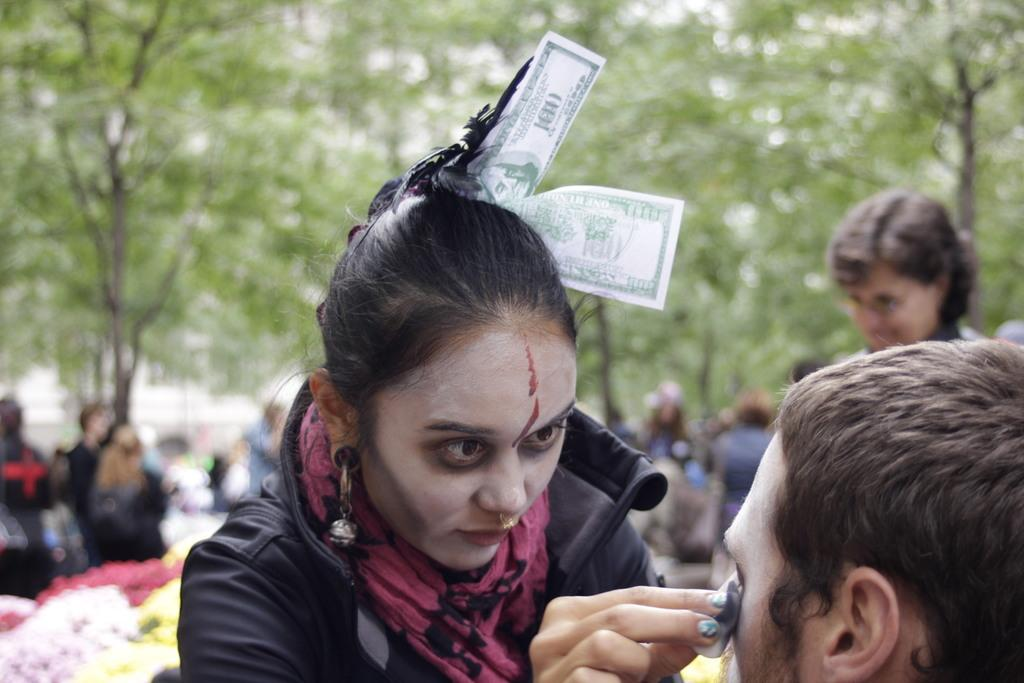What is the main subject of the image? There is a woman in the image. What is the woman holding in the image? The woman is holding an object. Can you describe the woman's appearance in the image? There is money in the woman's hair. What can be seen in the background of the image? There is a group of people, flowers, trees, and a building in the background of the image. What type of pen is the woman using to write on the plate in the image? There is no pen or plate present in the image. 